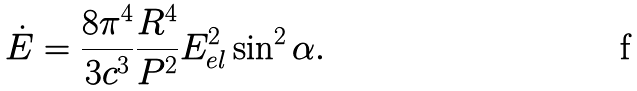<formula> <loc_0><loc_0><loc_500><loc_500>\dot { E } = \frac { 8 \pi ^ { 4 } } { 3 c ^ { 3 } } \frac { R ^ { 4 } } { P ^ { 2 } } E _ { e l } ^ { 2 } \sin ^ { 2 } \alpha .</formula> 